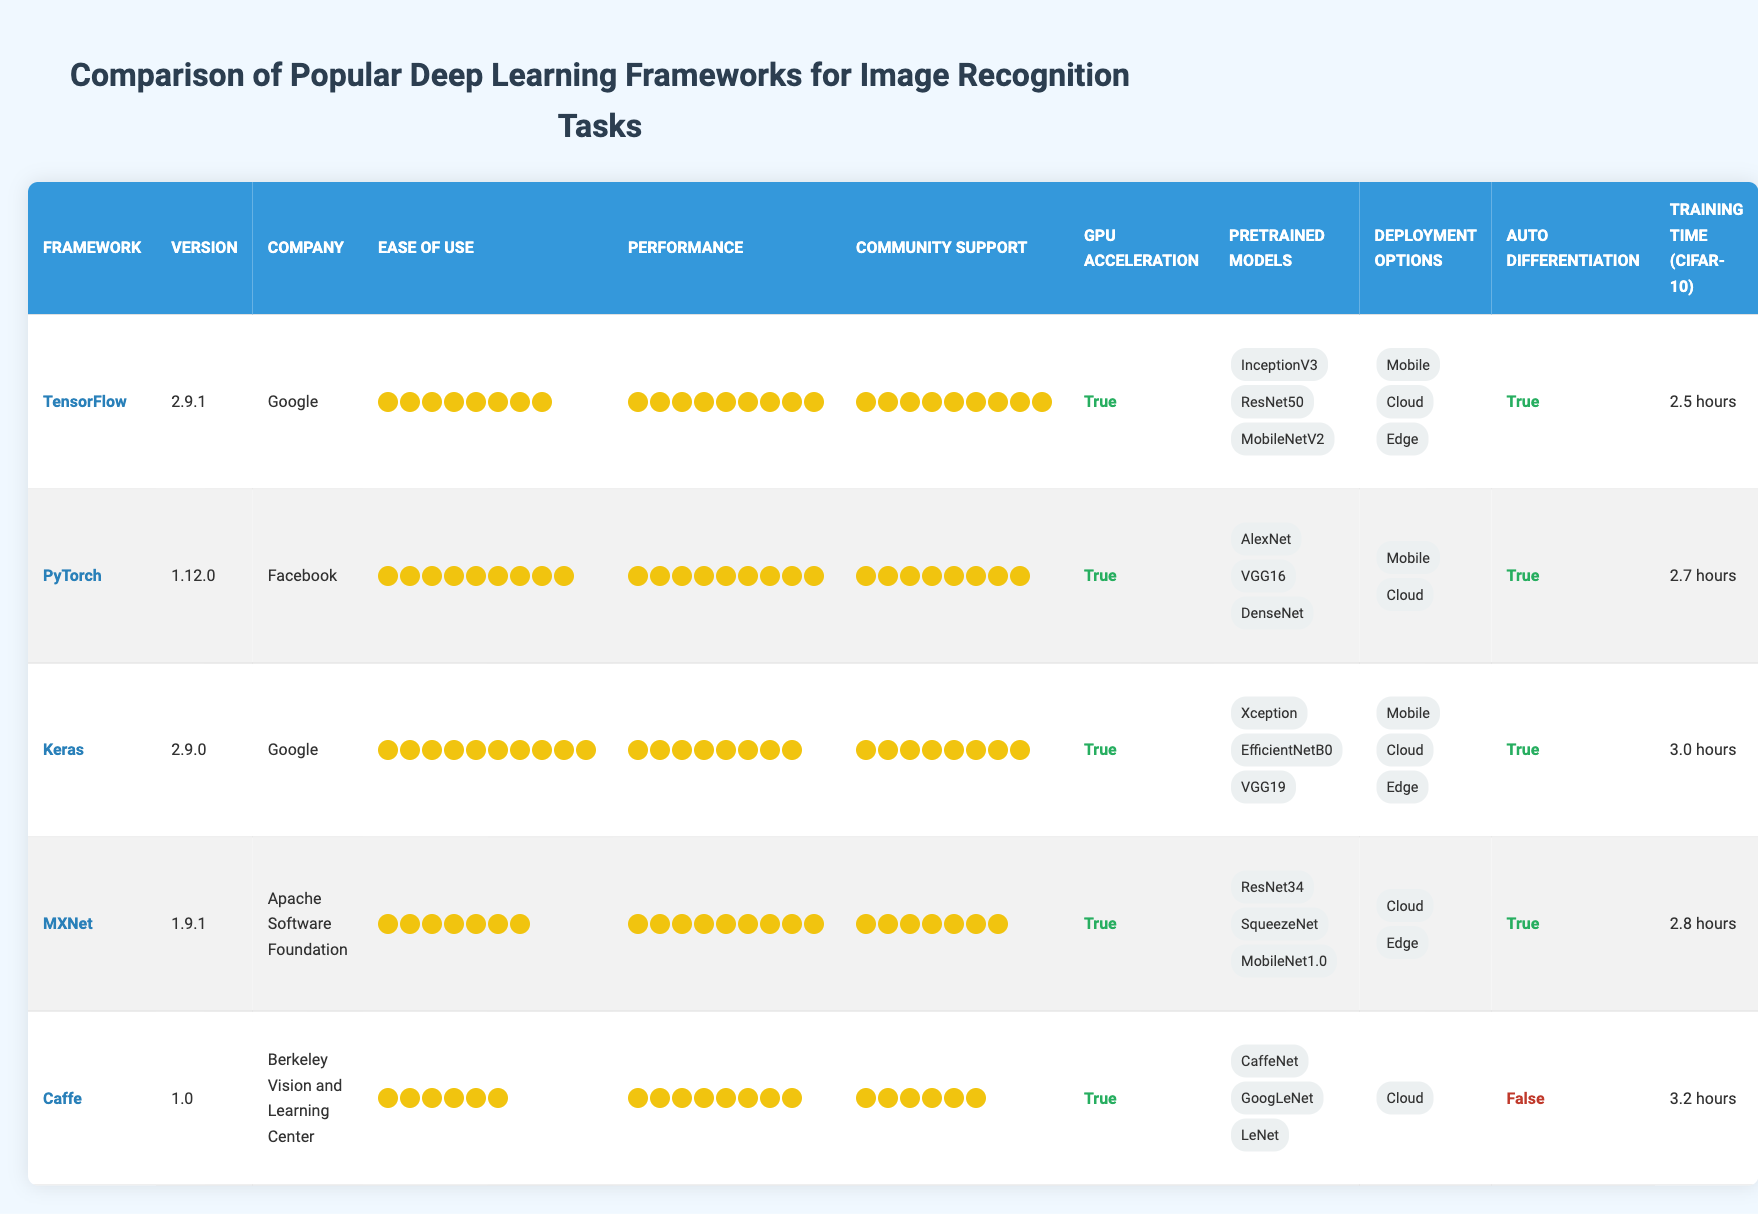What is the training time for TensorFlow on CIFAR-10? The training time for TensorFlow on CIFAR-10 is listed in the table under the "Training Time (CIFAR-10)" column for TensorFlow. It indicates "2.5 hours."
Answer: 2.5 hours Which framework has the highest ease of use rating? The ease of use ratings are listed for all frameworks. Keras has an ease of use rating of 10, which is higher than others.
Answer: Keras Does Caffe support auto differentiation? The table indicates whether each framework supports auto differentiation. For Caffe, it is labeled as "False" under the "Auto Differentiation" column.
Answer: No What is the average training time for the frameworks listed? The training times for the frameworks are: 2.5 hours (TensorFlow), 2.7 hours (PyTorch), 3.0 hours (Keras), 2.8 hours (MXNet), and 3.2 hours (Caffe). The total training time is 2.5 + 2.7 + 3.0 + 2.8 + 3.2 = 14.2 hours. The average is then 14.2 hours divided by 5 frameworks, which is 2.84 hours.
Answer: 2.84 hours Which framework has the most deployment options available? The deployment options for each framework are listed, showing that TensorFlow and Keras both support three deployment options (Mobile, Cloud, Edge), while others have either two or one option. TensorFlow and Keras tie for the most options.
Answer: TensorFlow and Keras Which framework has the least community support? The community support ratings indicate Caffe has the lowest rating, which is 6, making it the framework with the least support compared to others rated higher.
Answer: Caffe Are all frameworks capable of GPU acceleration? By reviewing the "GPU Acceleration" column, all listed frameworks (TensorFlow, PyTorch, Keras, MXNet, Caffe) indicate "True" for GPU acceleration support, confirming all frameworks have this capability.
Answer: Yes What is the combined performance rating for TensorFlow and Keras? The performance ratings for TensorFlow and Keras are both available. TensorFlow has a rating of 9, and Keras has a rating of 8. The sum of their ratings is 9 + 8 = 17.
Answer: 17 Which framework produced the longest training time on CIFAR-10? Checking the training times for each framework, Caffe has the longest training time of 3.2 hours, compared to others with shorter times.
Answer: Caffe 